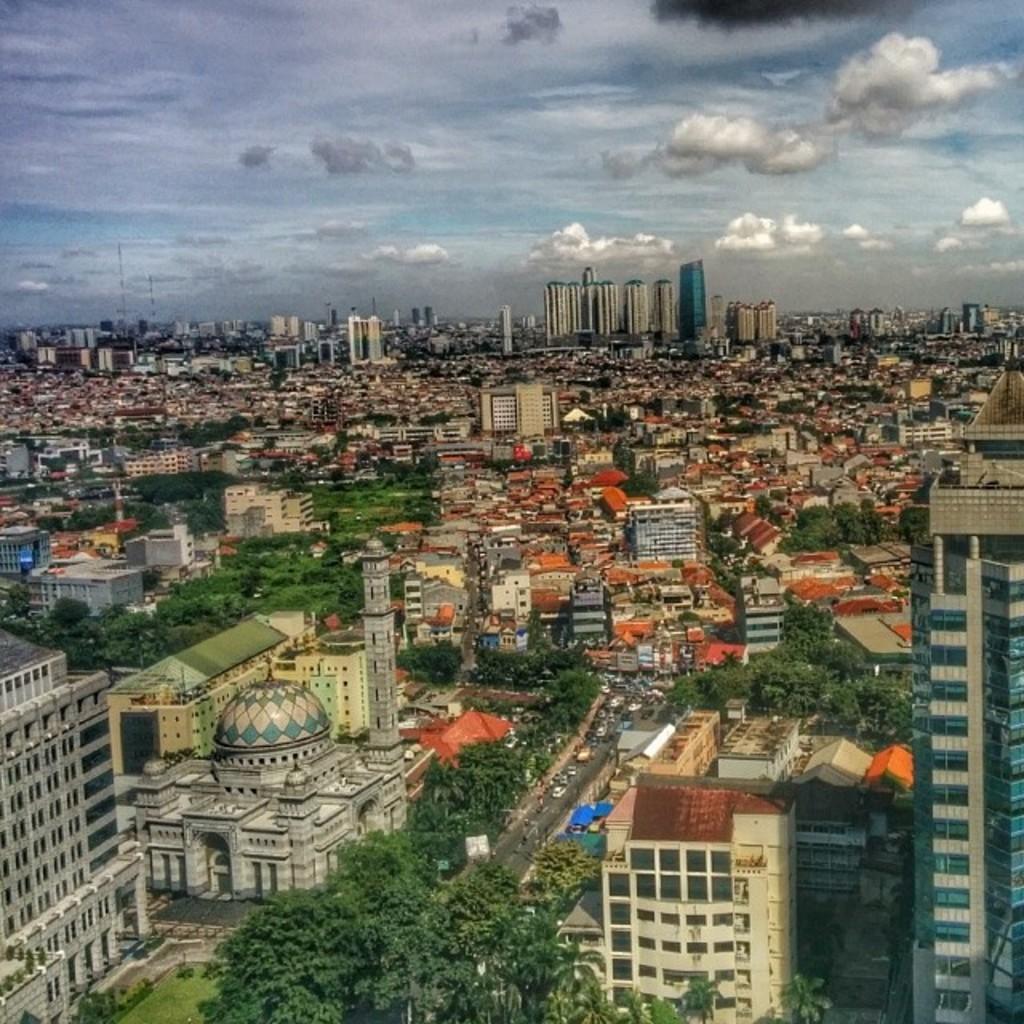Please provide a concise description of this image. Here this is an aerial view, in which we can see number of buildings and houses covered all over the place and we can also see plants and trees present on the ground and we can see vehicles present on the road and we can see clouds in the sky. 